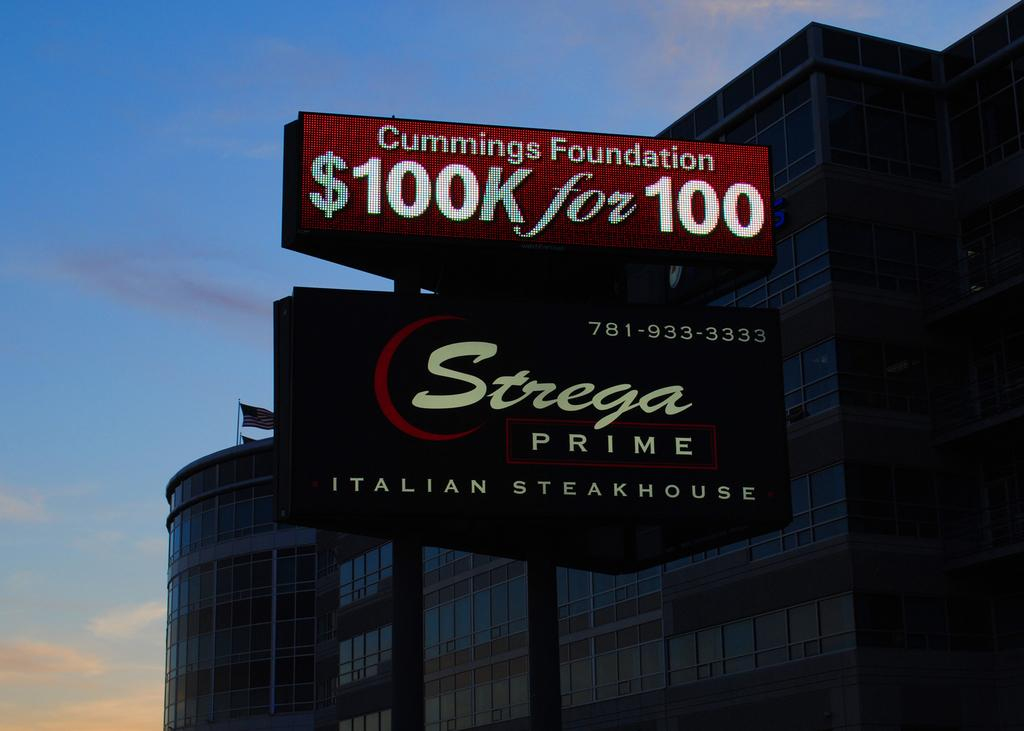<image>
Create a compact narrative representing the image presented. a sign with strega prime written on it 